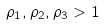<formula> <loc_0><loc_0><loc_500><loc_500>\rho _ { 1 } , \rho _ { 2 } , \rho _ { 3 } > 1</formula> 